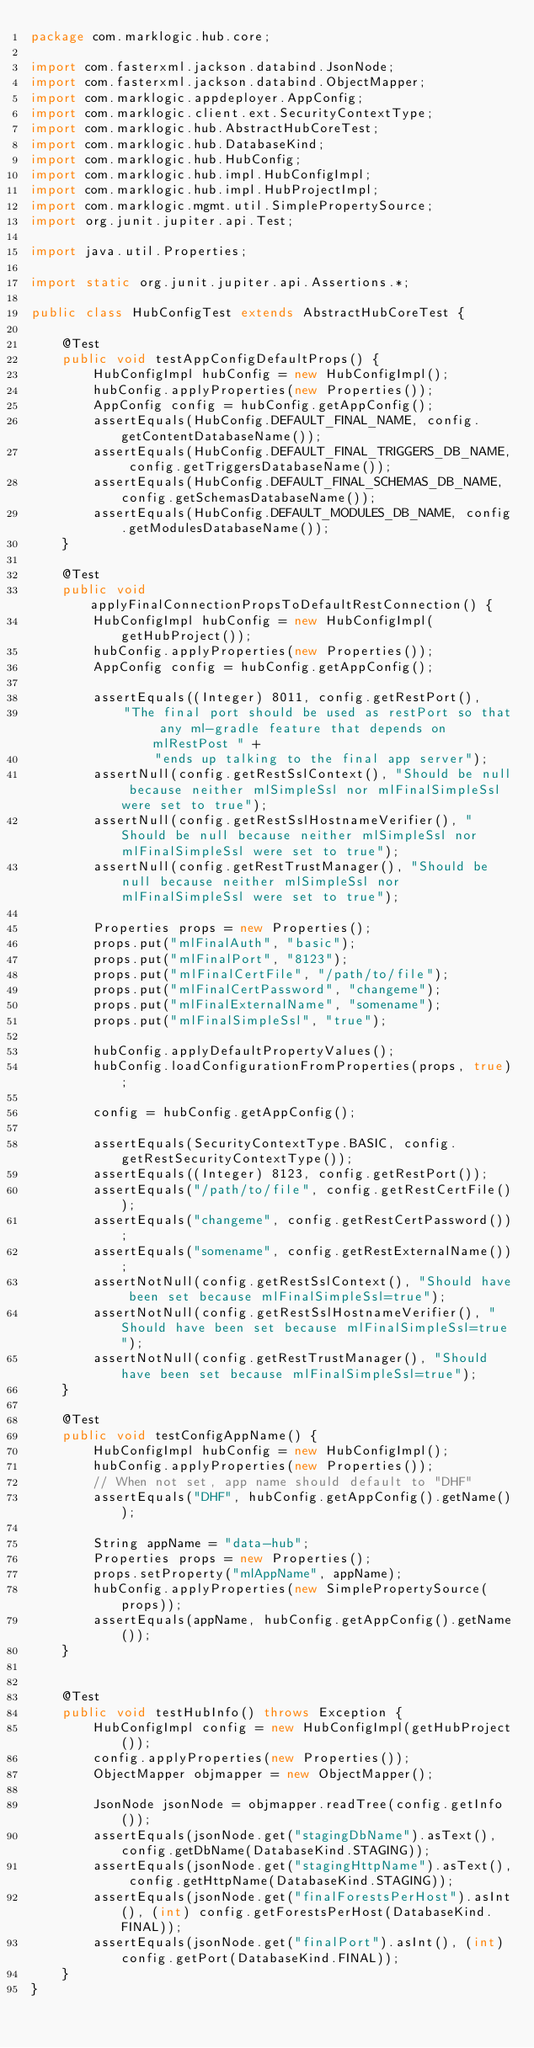<code> <loc_0><loc_0><loc_500><loc_500><_Java_>package com.marklogic.hub.core;

import com.fasterxml.jackson.databind.JsonNode;
import com.fasterxml.jackson.databind.ObjectMapper;
import com.marklogic.appdeployer.AppConfig;
import com.marklogic.client.ext.SecurityContextType;
import com.marklogic.hub.AbstractHubCoreTest;
import com.marklogic.hub.DatabaseKind;
import com.marklogic.hub.HubConfig;
import com.marklogic.hub.impl.HubConfigImpl;
import com.marklogic.hub.impl.HubProjectImpl;
import com.marklogic.mgmt.util.SimplePropertySource;
import org.junit.jupiter.api.Test;

import java.util.Properties;

import static org.junit.jupiter.api.Assertions.*;

public class HubConfigTest extends AbstractHubCoreTest {

    @Test
    public void testAppConfigDefaultProps() {
        HubConfigImpl hubConfig = new HubConfigImpl();
        hubConfig.applyProperties(new Properties());
        AppConfig config = hubConfig.getAppConfig();
        assertEquals(HubConfig.DEFAULT_FINAL_NAME, config.getContentDatabaseName());
        assertEquals(HubConfig.DEFAULT_FINAL_TRIGGERS_DB_NAME, config.getTriggersDatabaseName());
        assertEquals(HubConfig.DEFAULT_FINAL_SCHEMAS_DB_NAME, config.getSchemasDatabaseName());
        assertEquals(HubConfig.DEFAULT_MODULES_DB_NAME, config.getModulesDatabaseName());
    }

    @Test
    public void applyFinalConnectionPropsToDefaultRestConnection() {
        HubConfigImpl hubConfig = new HubConfigImpl(getHubProject());
        hubConfig.applyProperties(new Properties());
        AppConfig config = hubConfig.getAppConfig();

        assertEquals((Integer) 8011, config.getRestPort(),
            "The final port should be used as restPort so that any ml-gradle feature that depends on mlRestPost " +
                "ends up talking to the final app server");
        assertNull(config.getRestSslContext(), "Should be null because neither mlSimpleSsl nor mlFinalSimpleSsl were set to true");
        assertNull(config.getRestSslHostnameVerifier(), "Should be null because neither mlSimpleSsl nor mlFinalSimpleSsl were set to true");
        assertNull(config.getRestTrustManager(), "Should be null because neither mlSimpleSsl nor mlFinalSimpleSsl were set to true");

        Properties props = new Properties();
        props.put("mlFinalAuth", "basic");
        props.put("mlFinalPort", "8123");
        props.put("mlFinalCertFile", "/path/to/file");
        props.put("mlFinalCertPassword", "changeme");
        props.put("mlFinalExternalName", "somename");
        props.put("mlFinalSimpleSsl", "true");

        hubConfig.applyDefaultPropertyValues();
        hubConfig.loadConfigurationFromProperties(props, true);

        config = hubConfig.getAppConfig();

        assertEquals(SecurityContextType.BASIC, config.getRestSecurityContextType());
        assertEquals((Integer) 8123, config.getRestPort());
        assertEquals("/path/to/file", config.getRestCertFile());
        assertEquals("changeme", config.getRestCertPassword());
        assertEquals("somename", config.getRestExternalName());
        assertNotNull(config.getRestSslContext(), "Should have been set because mlFinalSimpleSsl=true");
        assertNotNull(config.getRestSslHostnameVerifier(), "Should have been set because mlFinalSimpleSsl=true");
        assertNotNull(config.getRestTrustManager(), "Should have been set because mlFinalSimpleSsl=true");
    }

    @Test
    public void testConfigAppName() {
        HubConfigImpl hubConfig = new HubConfigImpl();
        hubConfig.applyProperties(new Properties());
        // When not set, app name should default to "DHF"
        assertEquals("DHF", hubConfig.getAppConfig().getName());

        String appName = "data-hub";
        Properties props = new Properties();
        props.setProperty("mlAppName", appName);
        hubConfig.applyProperties(new SimplePropertySource(props));
        assertEquals(appName, hubConfig.getAppConfig().getName());
    }


    @Test
    public void testHubInfo() throws Exception {
        HubConfigImpl config = new HubConfigImpl(getHubProject());
        config.applyProperties(new Properties());
        ObjectMapper objmapper = new ObjectMapper();

        JsonNode jsonNode = objmapper.readTree(config.getInfo());
        assertEquals(jsonNode.get("stagingDbName").asText(), config.getDbName(DatabaseKind.STAGING));
        assertEquals(jsonNode.get("stagingHttpName").asText(), config.getHttpName(DatabaseKind.STAGING));
        assertEquals(jsonNode.get("finalForestsPerHost").asInt(), (int) config.getForestsPerHost(DatabaseKind.FINAL));
        assertEquals(jsonNode.get("finalPort").asInt(), (int) config.getPort(DatabaseKind.FINAL));
    }
}
</code> 